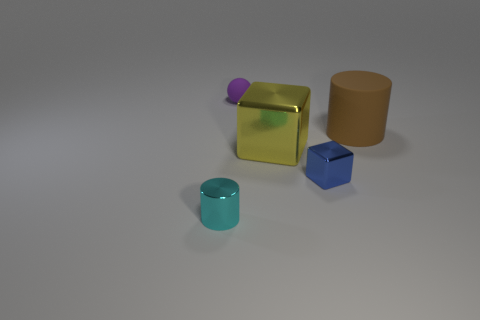Are there more yellow metal objects in front of the cyan cylinder than yellow things that are behind the brown thing?
Offer a very short reply. No. What is the color of the cylinder behind the tiny cyan metal cylinder?
Your response must be concise. Brown. There is a tiny thing on the right side of the tiny purple matte ball; does it have the same shape as the matte object that is on the right side of the large yellow cube?
Offer a terse response. No. Are there any blue things that have the same size as the cyan cylinder?
Your answer should be compact. Yes. What is the material of the cube on the left side of the blue metallic cube?
Offer a very short reply. Metal. Is the material of the cylinder on the left side of the large matte cylinder the same as the small cube?
Give a very brief answer. Yes. Are there any small blue metallic cubes?
Keep it short and to the point. Yes. There is a tiny object that is made of the same material as the tiny blue block; what color is it?
Provide a short and direct response. Cyan. There is a tiny shiny thing that is left of the small metallic object that is behind the object that is left of the tiny matte thing; what color is it?
Keep it short and to the point. Cyan. Is the size of the brown thing the same as the blue shiny block that is on the right side of the purple matte ball?
Your answer should be very brief. No. 